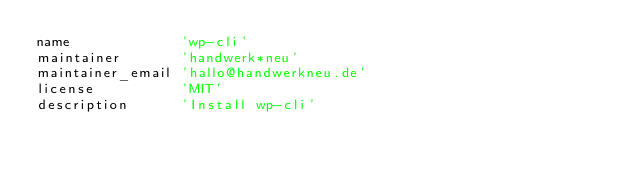<code> <loc_0><loc_0><loc_500><loc_500><_Ruby_>name             'wp-cli'
maintainer       'handwerk*neu'
maintainer_email 'hallo@handwerkneu.de'
license          'MIT'
description      'Install wp-cli'</code> 